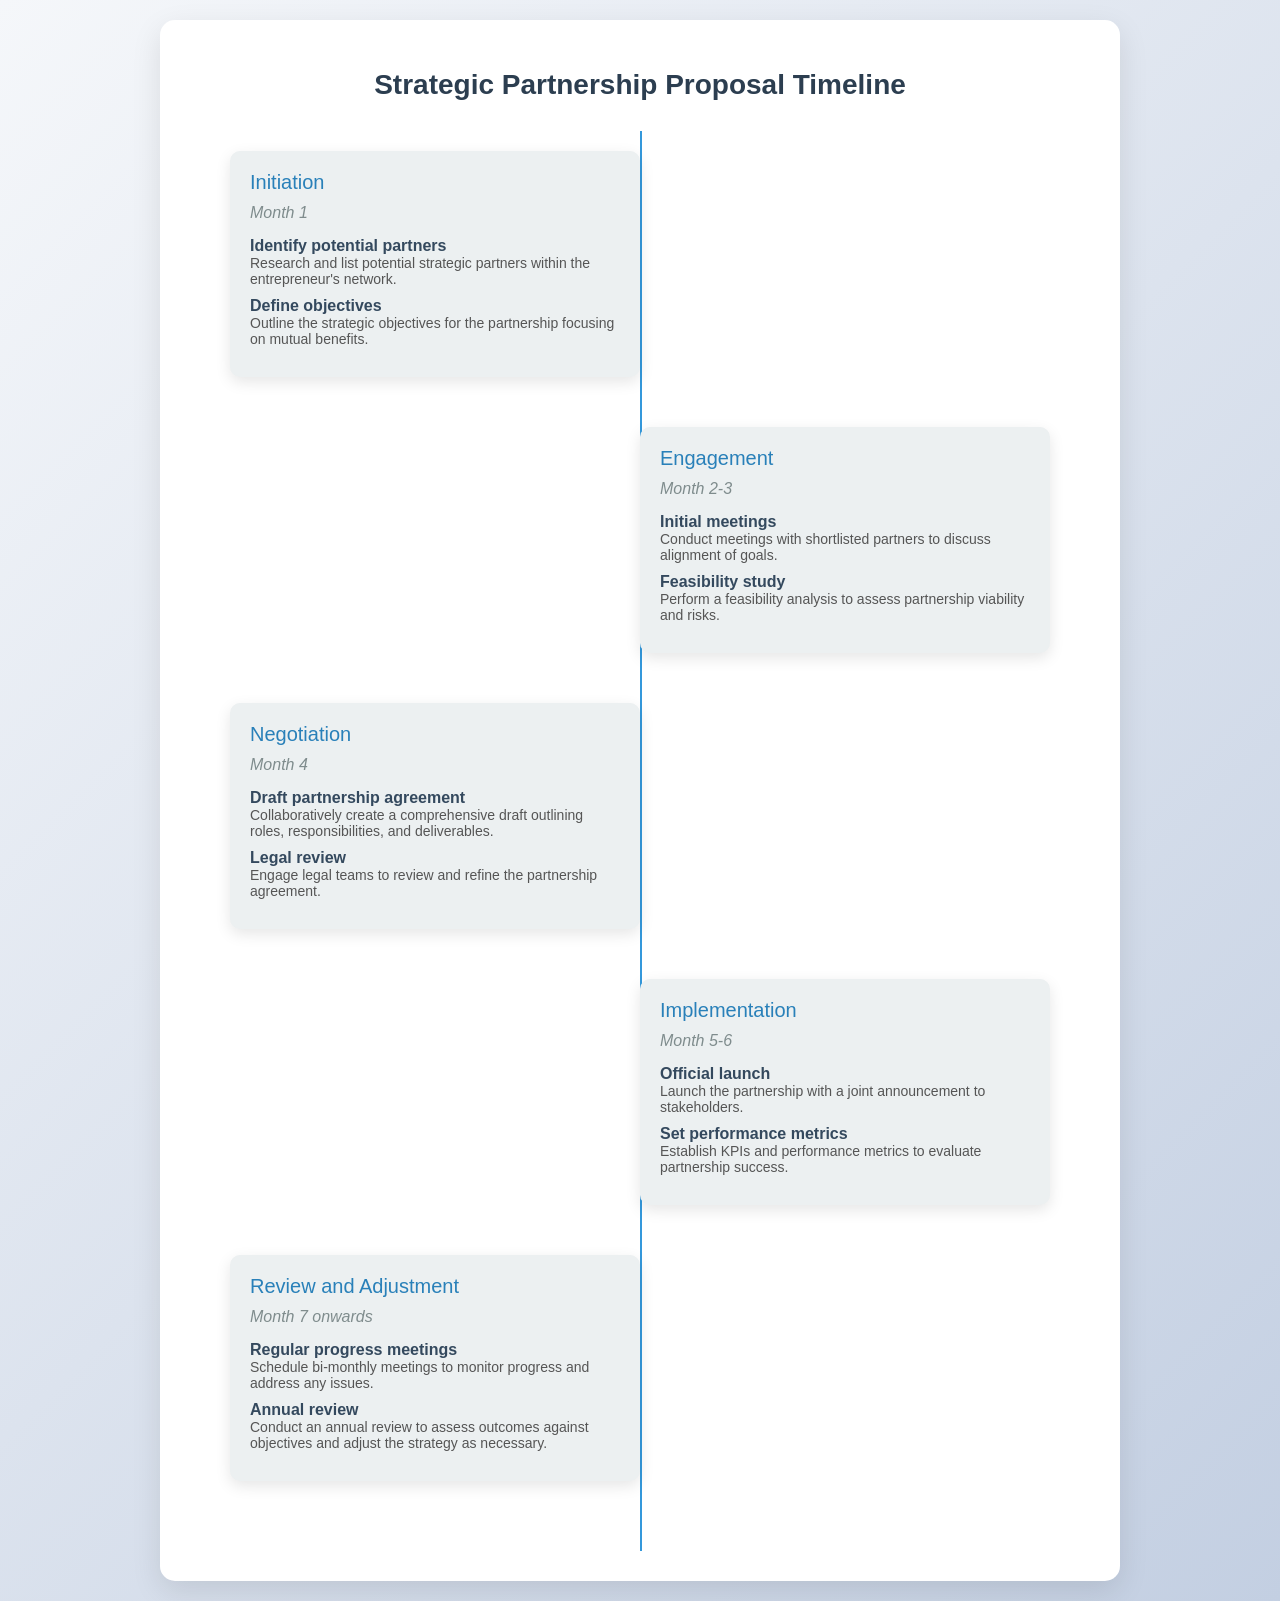What is the first phase in the partnership timeline? The first phase listed in the document is "Initiation."
Answer: Initiation How long does the Engagement phase last? The Engagement phase spans from Month 2 to Month 3.
Answer: Month 2-3 What is the main focus of the Implementation phase? The Implementation phase emphasizes the official launch and setting performance metrics.
Answer: Official launch and set performance metrics How many milestones are there in the Review and Adjustment phase? There are two milestones listed in the Review and Adjustment phase.
Answer: Two When does the Review and Adjustment phase start? The Review and Adjustment phase starts in Month 7 onwards.
Answer: Month 7 onwards What is one of the objectives defined in the Initiation phase? One objective is to outline the strategic objectives for the partnership.
Answer: Outline strategic objectives What is the last milestone mentioned in the timeline? The last milestone is the "Annual review."
Answer: Annual review What type of meetings are scheduled during the Review and Adjustment phase? The meetings scheduled are "Regular progress meetings."
Answer: Regular progress meetings In which month does the Negotiation phase occur? The Negotiation phase occurs in Month 4.
Answer: Month 4 